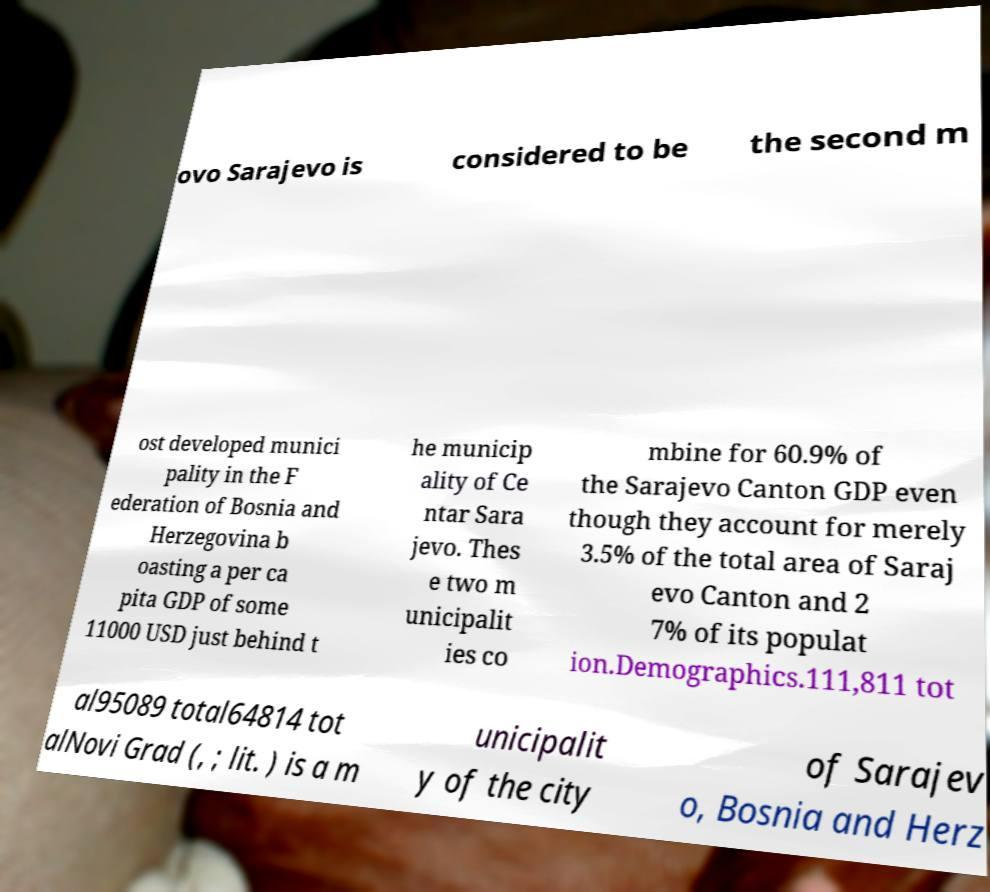Could you assist in decoding the text presented in this image and type it out clearly? ovo Sarajevo is considered to be the second m ost developed munici pality in the F ederation of Bosnia and Herzegovina b oasting a per ca pita GDP of some 11000 USD just behind t he municip ality of Ce ntar Sara jevo. Thes e two m unicipalit ies co mbine for 60.9% of the Sarajevo Canton GDP even though they account for merely 3.5% of the total area of Saraj evo Canton and 2 7% of its populat ion.Demographics.111,811 tot al95089 total64814 tot alNovi Grad (, ; lit. ) is a m unicipalit y of the city of Sarajev o, Bosnia and Herz 